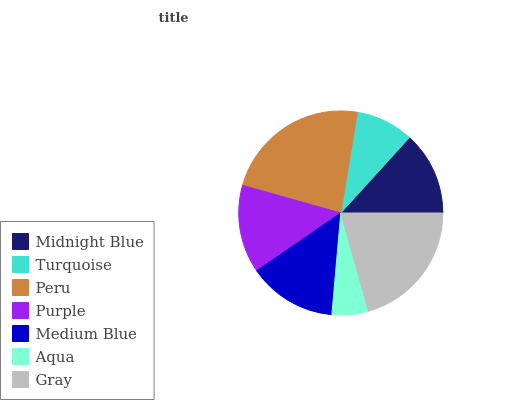Is Aqua the minimum?
Answer yes or no. Yes. Is Peru the maximum?
Answer yes or no. Yes. Is Turquoise the minimum?
Answer yes or no. No. Is Turquoise the maximum?
Answer yes or no. No. Is Midnight Blue greater than Turquoise?
Answer yes or no. Yes. Is Turquoise less than Midnight Blue?
Answer yes or no. Yes. Is Turquoise greater than Midnight Blue?
Answer yes or no. No. Is Midnight Blue less than Turquoise?
Answer yes or no. No. Is Purple the high median?
Answer yes or no. Yes. Is Purple the low median?
Answer yes or no. Yes. Is Medium Blue the high median?
Answer yes or no. No. Is Medium Blue the low median?
Answer yes or no. No. 